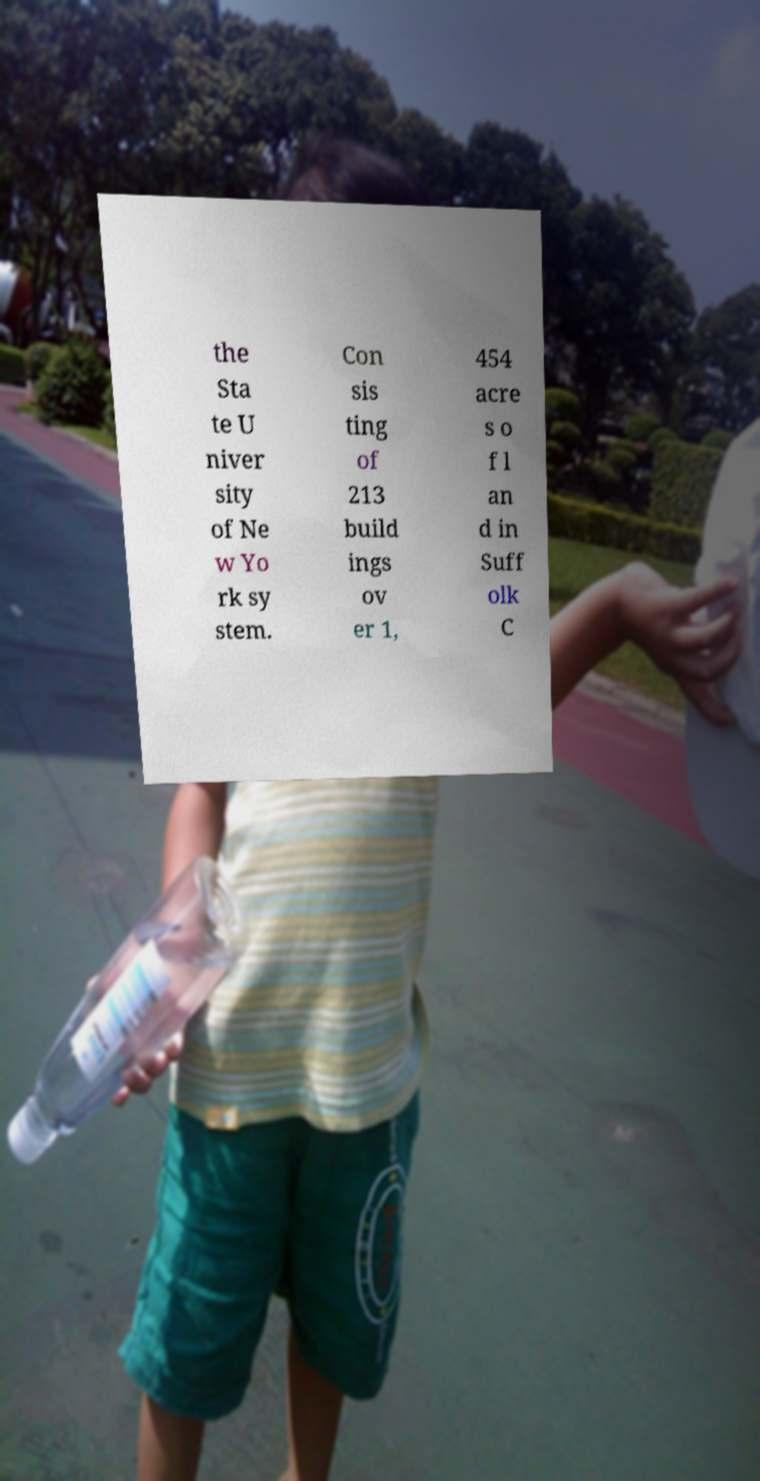Please identify and transcribe the text found in this image. the Sta te U niver sity of Ne w Yo rk sy stem. Con sis ting of 213 build ings ov er 1, 454 acre s o f l an d in Suff olk C 